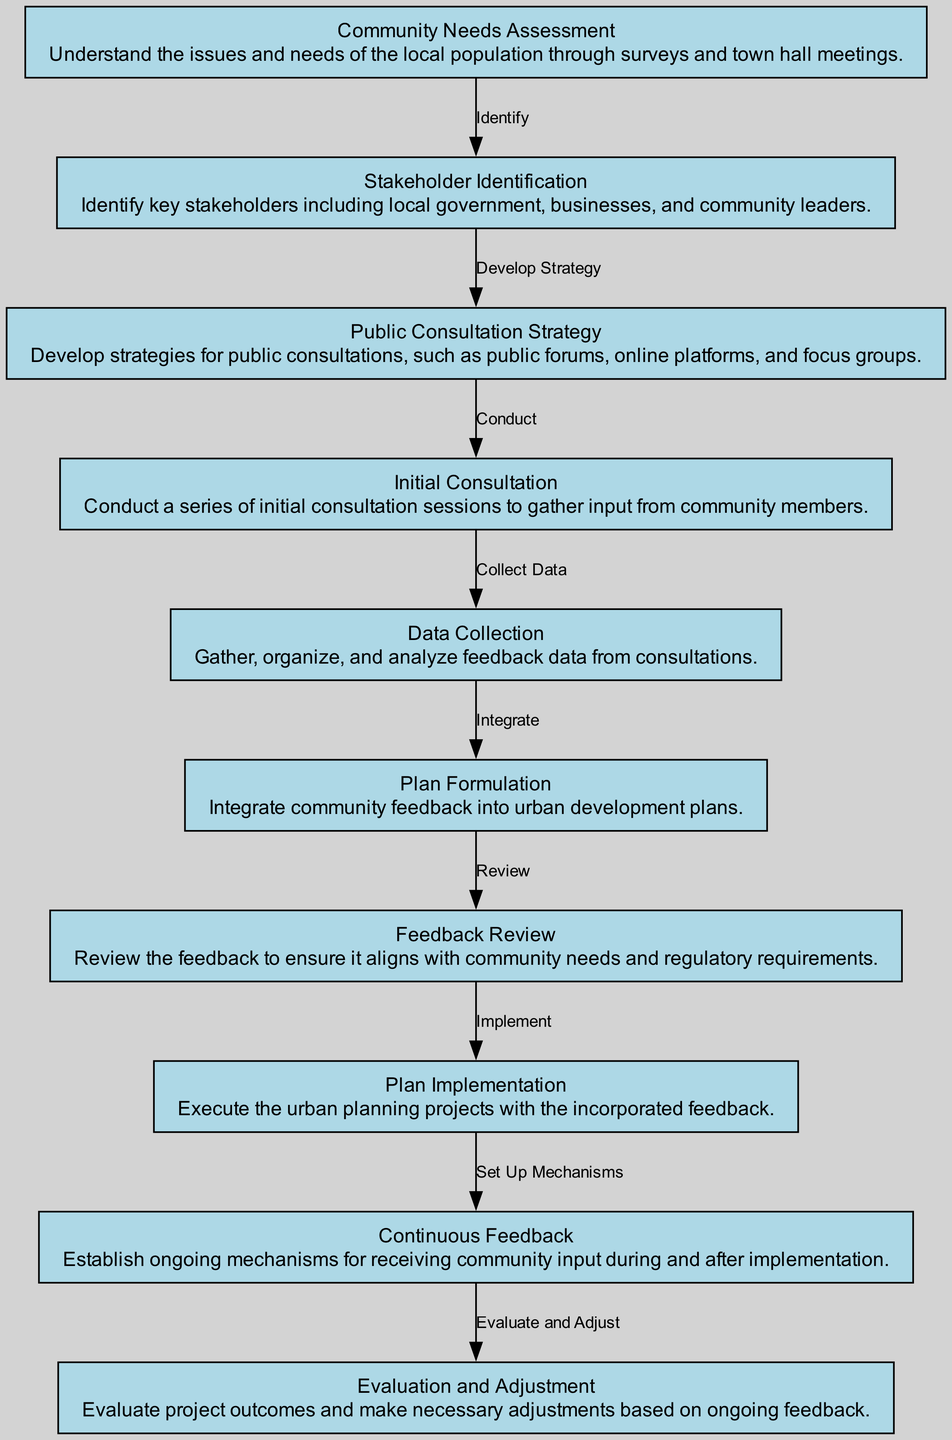What is the first step in the diagram? The first step in the diagram is the "Community Needs Assessment". This can be identified by looking at the nodes in the diagram and observing that it is the starting point from which all other activities branch off.
Answer: Community Needs Assessment How many nodes are present in the diagram? By counting each individual point in the node list, we find that there are 10 distinct nodes that represent various steps in the community engagement process.
Answer: 10 What follows after stakeholder identification? After "Stakeholder Identification", the next step in the process is "Public Consultation Strategy". This flow can be traced by observing the arrows indicating the order of actions in the diagram.
Answer: Public Consultation Strategy Which step collects feedback data? The "Data Collection" step specifically focuses on gathering feedback data. This can be seen as it is directly connected to "Initial Consultation" where the feedback is sourced, and leads into the analysis phase.
Answer: Data Collection What is the purpose of the "Feedback Review" step? The purpose of the "Feedback Review" step is to review the data collected to ensure it aligns with community needs and regulatory requirements. This can be derived from the description associated with that node in the diagram.
Answer: Review alignment with needs and regulations What is the final step after "Continuous Feedback"? The final step following "Continuous Feedback" is "Evaluation and Adjustment". This conclusion can be derived by following the arrows leading from one node to the next, ending at the last action specified in the flow.
Answer: Evaluation and Adjustment How does the plan implementation relate to community input? "Plan Implementation" involves executing urban planning projects based on community feedback that has been integrated earlier in the process. This relationship is noted in the flow progression from "Plan Formulation" to "Feedback Review" and ultimately to "Plan Implementation".
Answer: Executes projects with feedback What type of consultation strategies can be developed? The "Public Consultation Strategy" can include public forums, online platforms, and focus groups, as indicated in the node description detailing the broad approach to engaging with the community.
Answer: Public forums, online platforms, focus groups What step comes after "Data Collection"? Following "Data Collection", the next step is "Plan Formulation". This can be confirmed by looking at the progression of actions as defined by the edges connecting the nodes in the diagram.
Answer: Plan Formulation 